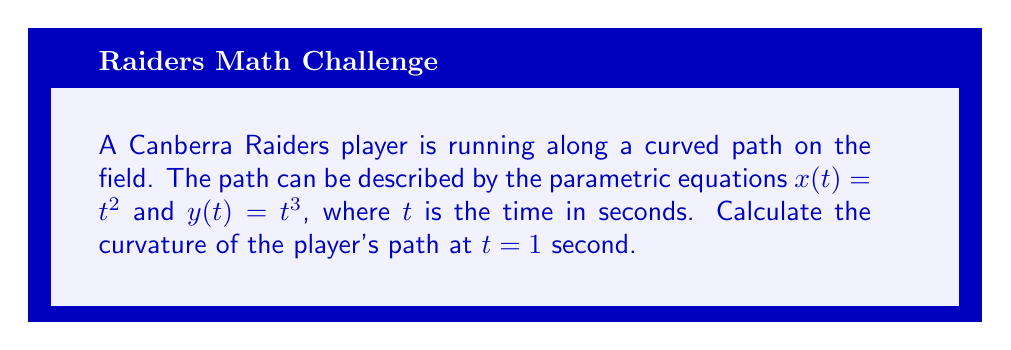Solve this math problem. To find the curvature of the player's path, we'll use the formula for curvature in parametric form:

$$\kappa = \frac{|x'y'' - y'x''|}{(x'^2 + y'^2)^{3/2}}$$

Step 1: Calculate the first derivatives
$x'(t) = 2t$
$y'(t) = 3t^2$

Step 2: Calculate the second derivatives
$x''(t) = 2$
$y''(t) = 6t$

Step 3: Evaluate the derivatives at $t = 1$
$x'(1) = 2$
$y'(1) = 3$
$x''(1) = 2$
$y''(1) = 6$

Step 4: Calculate the numerator of the curvature formula
$|x'y'' - y'x''| = |2(6) - 3(2)| = |12 - 6| = 6$

Step 5: Calculate the denominator of the curvature formula
$(x'^2 + y'^2)^{3/2} = (2^2 + 3^2)^{3/2} = (4 + 9)^{3/2} = 13^{3/2}$

Step 6: Combine the numerator and denominator to get the final curvature
$$\kappa = \frac{6}{13^{3/2}}$$
Answer: $\frac{6}{13^{3/2}}$ 